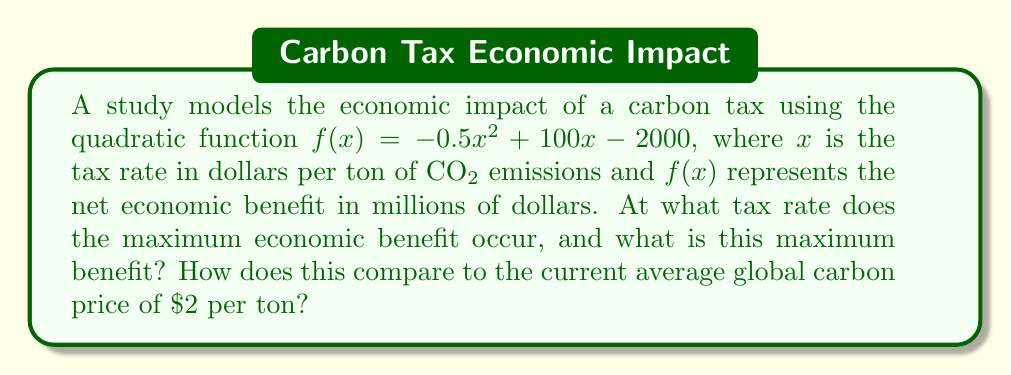What is the answer to this math problem? 1) To find the maximum of a quadratic function, we need to find the vertex. For a quadratic function in the form $f(x) = ax^2 + bx + c$, the x-coordinate of the vertex is given by $x = -\frac{b}{2a}$.

2) In our function $f(x) = -0.5x^2 + 100x - 2000$, we have:
   $a = -0.5$
   $b = 100$
   $c = -2000$

3) Calculating the x-coordinate of the vertex:
   $x = -\frac{b}{2a} = -\frac{100}{2(-0.5)} = \frac{100}{-1} = 100$

4) The maximum benefit occurs at a tax rate of $100 per ton.

5) To find the maximum benefit, we substitute $x = 100$ into our original function:
   $f(100) = -0.5(100)^2 + 100(100) - 2000$
           $= -0.5(10000) + 10000 - 2000$
           $= -5000 + 10000 - 2000$
           $= 3000$

6) The maximum economic benefit is $3000 million, or $3 billion.

7) Comparing to the current average global carbon price of $2 per ton:
   The optimal tax rate ($100) is 50 times higher than the current average.
   At $x = 2$, $f(2) = -0.5(2)^2 + 100(2) - 2000 = -2 + 200 - 2000 = -1802$
   This represents a net economic loss of $1.802 billion at the current average price.
Answer: Maximum benefit of $3 billion occurs at $100/ton; 50 times higher than current $2/ton average, which results in $1.802 billion loss. 